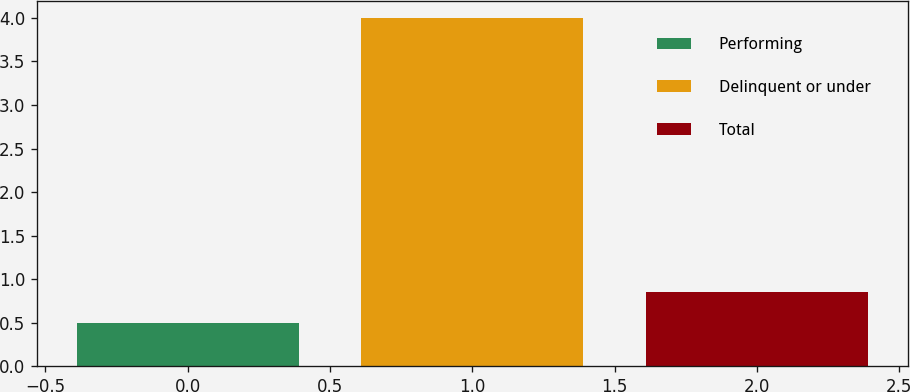Convert chart to OTSL. <chart><loc_0><loc_0><loc_500><loc_500><bar_chart><fcel>Performing<fcel>Delinquent or under<fcel>Total<nl><fcel>0.5<fcel>4<fcel>0.85<nl></chart> 